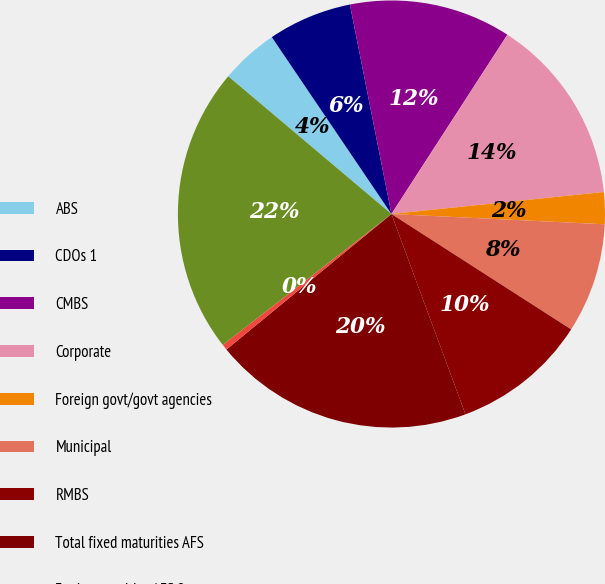Convert chart. <chart><loc_0><loc_0><loc_500><loc_500><pie_chart><fcel>ABS<fcel>CDOs 1<fcel>CMBS<fcel>Corporate<fcel>Foreign govt/govt agencies<fcel>Municipal<fcel>RMBS<fcel>Total fixed maturities AFS<fcel>Equity securities AFS 2<fcel>Total securities in an<nl><fcel>4.38%<fcel>6.35%<fcel>12.25%<fcel>14.22%<fcel>2.41%<fcel>8.32%<fcel>10.28%<fcel>19.69%<fcel>0.44%<fcel>21.66%<nl></chart> 